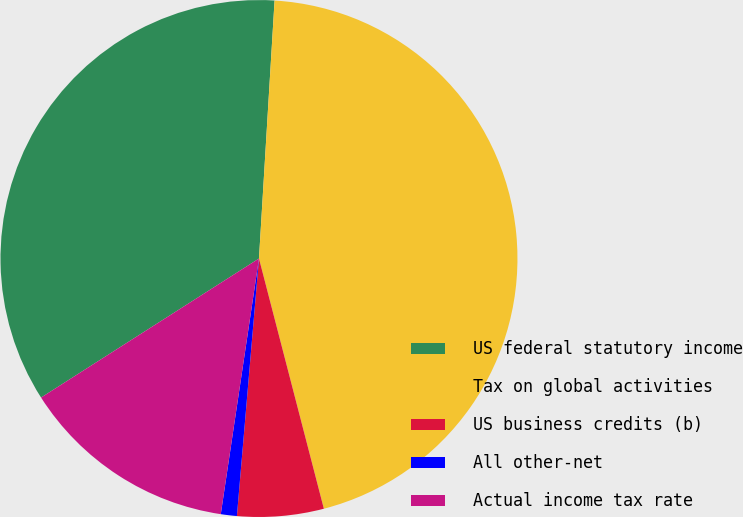<chart> <loc_0><loc_0><loc_500><loc_500><pie_chart><fcel>US federal statutory income<fcel>Tax on global activities<fcel>US business credits (b)<fcel>All other-net<fcel>Actual income tax rate<nl><fcel>35.0%<fcel>45.0%<fcel>5.4%<fcel>1.0%<fcel>13.6%<nl></chart> 